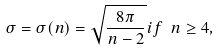<formula> <loc_0><loc_0><loc_500><loc_500>\sigma = \sigma ( n ) = \sqrt { \frac { 8 \pi } { n - 2 } } i f \ n \geq 4 ,</formula> 